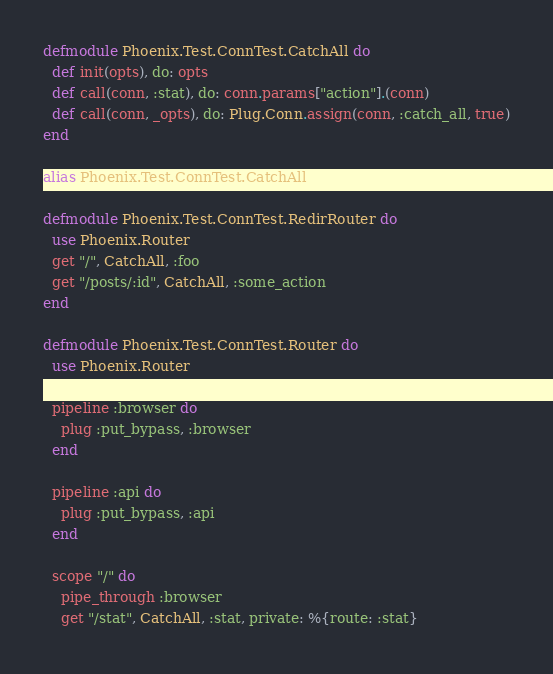<code> <loc_0><loc_0><loc_500><loc_500><_Elixir_>defmodule Phoenix.Test.ConnTest.CatchAll do
  def init(opts), do: opts
  def call(conn, :stat), do: conn.params["action"].(conn)
  def call(conn, _opts), do: Plug.Conn.assign(conn, :catch_all, true)
end

alias Phoenix.Test.ConnTest.CatchAll

defmodule Phoenix.Test.ConnTest.RedirRouter do
  use Phoenix.Router
  get "/", CatchAll, :foo
  get "/posts/:id", CatchAll, :some_action
end

defmodule Phoenix.Test.ConnTest.Router do
  use Phoenix.Router

  pipeline :browser do
    plug :put_bypass, :browser
  end

  pipeline :api do
    plug :put_bypass, :api
  end

  scope "/" do
    pipe_through :browser
    get "/stat", CatchAll, :stat, private: %{route: :stat}</code> 